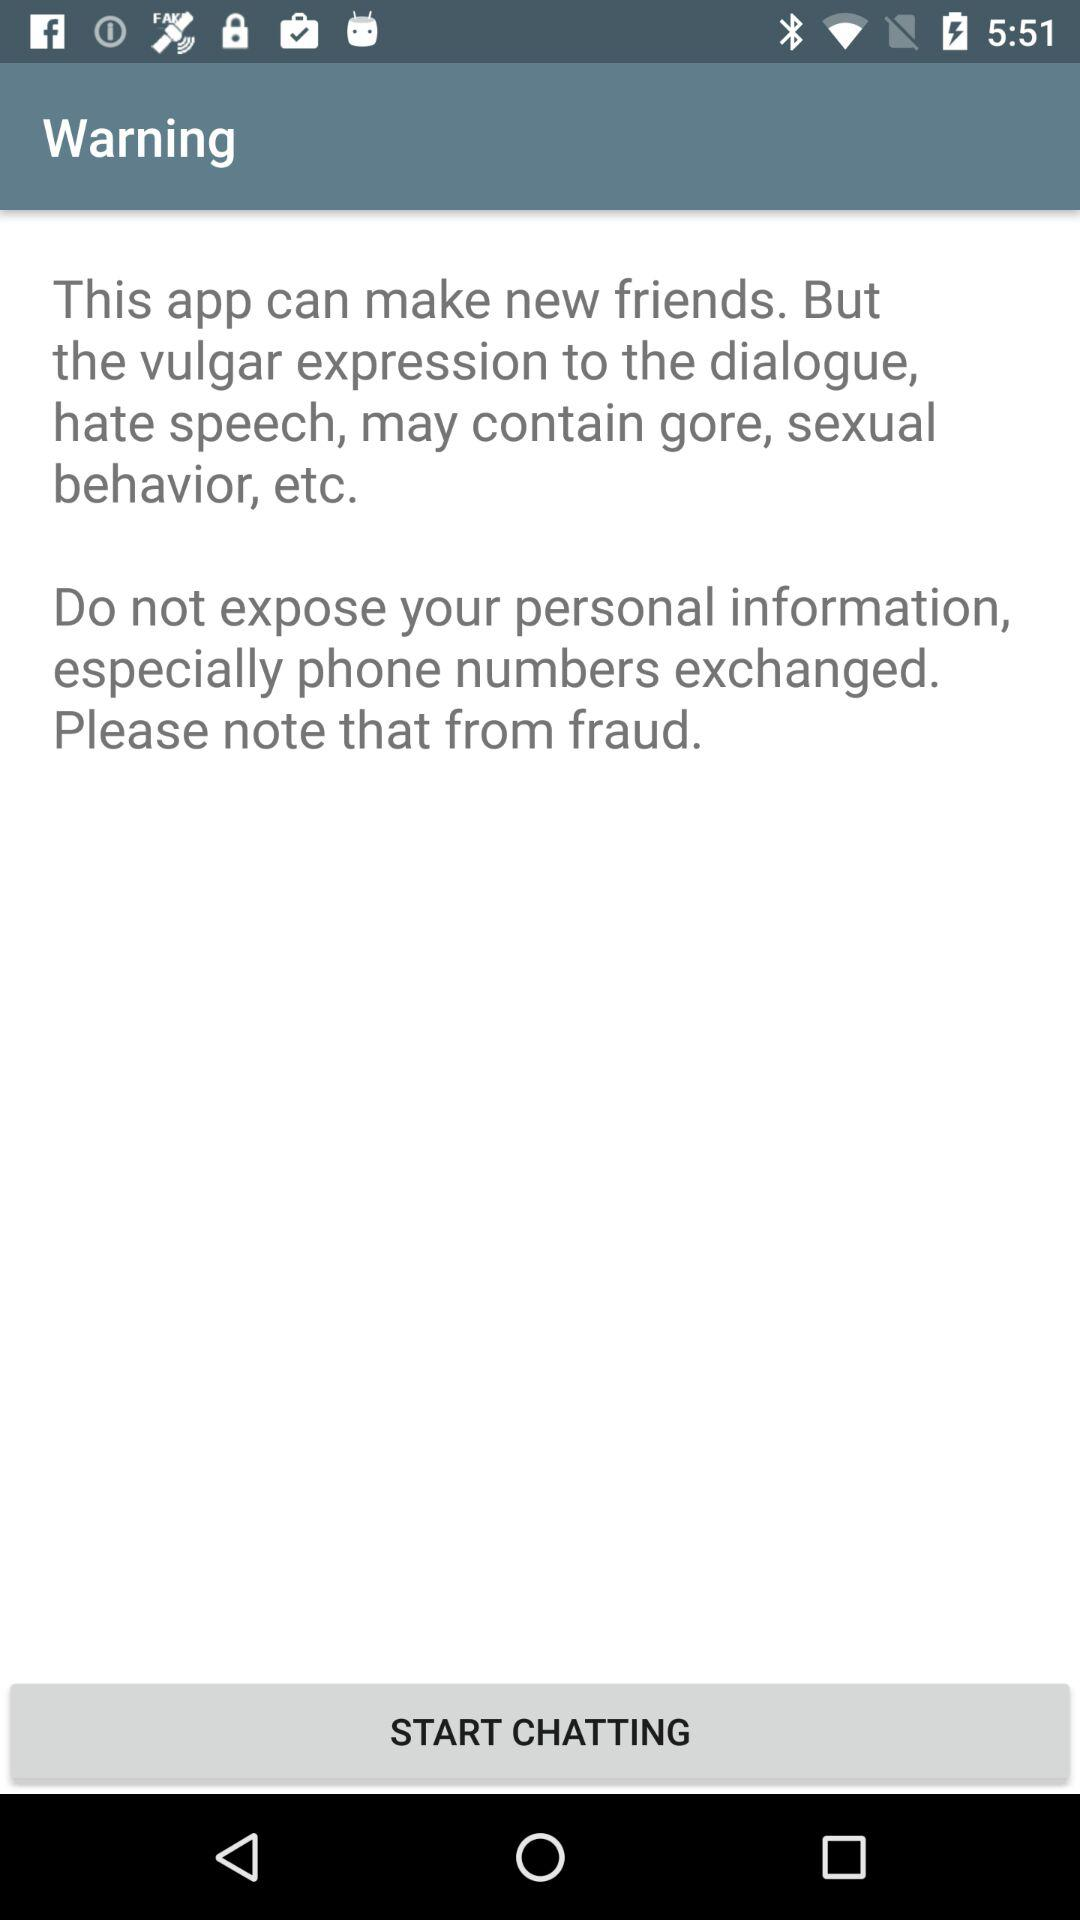What does an expression shows?
When the provided information is insufficient, respond with <no answer>. <no answer> 